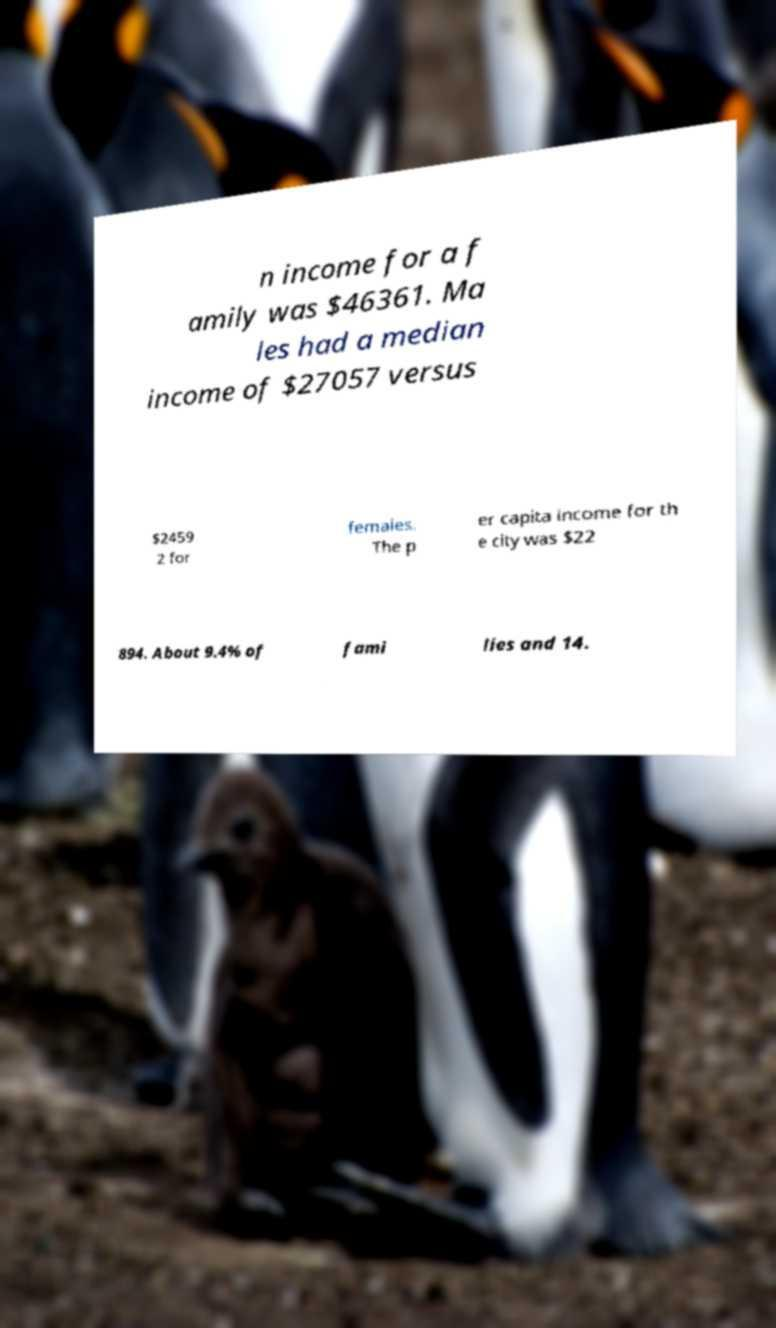Please identify and transcribe the text found in this image. n income for a f amily was $46361. Ma les had a median income of $27057 versus $2459 2 for females. The p er capita income for th e city was $22 894. About 9.4% of fami lies and 14. 